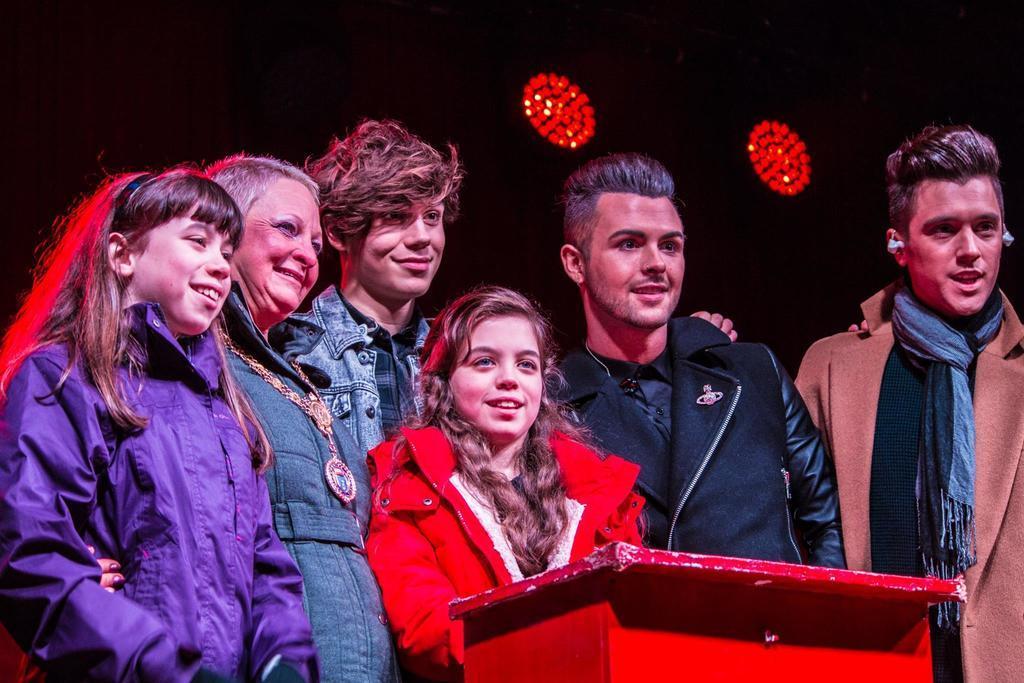Can you describe this image briefly? In this image I can see few people are standing, smiling and looking at the right side. In front of these people I can see a red color table. In the background I can see some red color lights. 